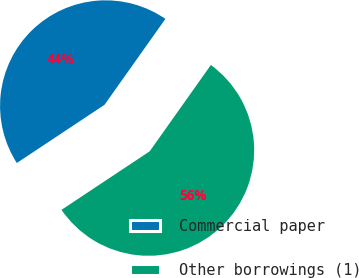Convert chart. <chart><loc_0><loc_0><loc_500><loc_500><pie_chart><fcel>Commercial paper<fcel>Other borrowings (1)<nl><fcel>44.14%<fcel>55.86%<nl></chart> 